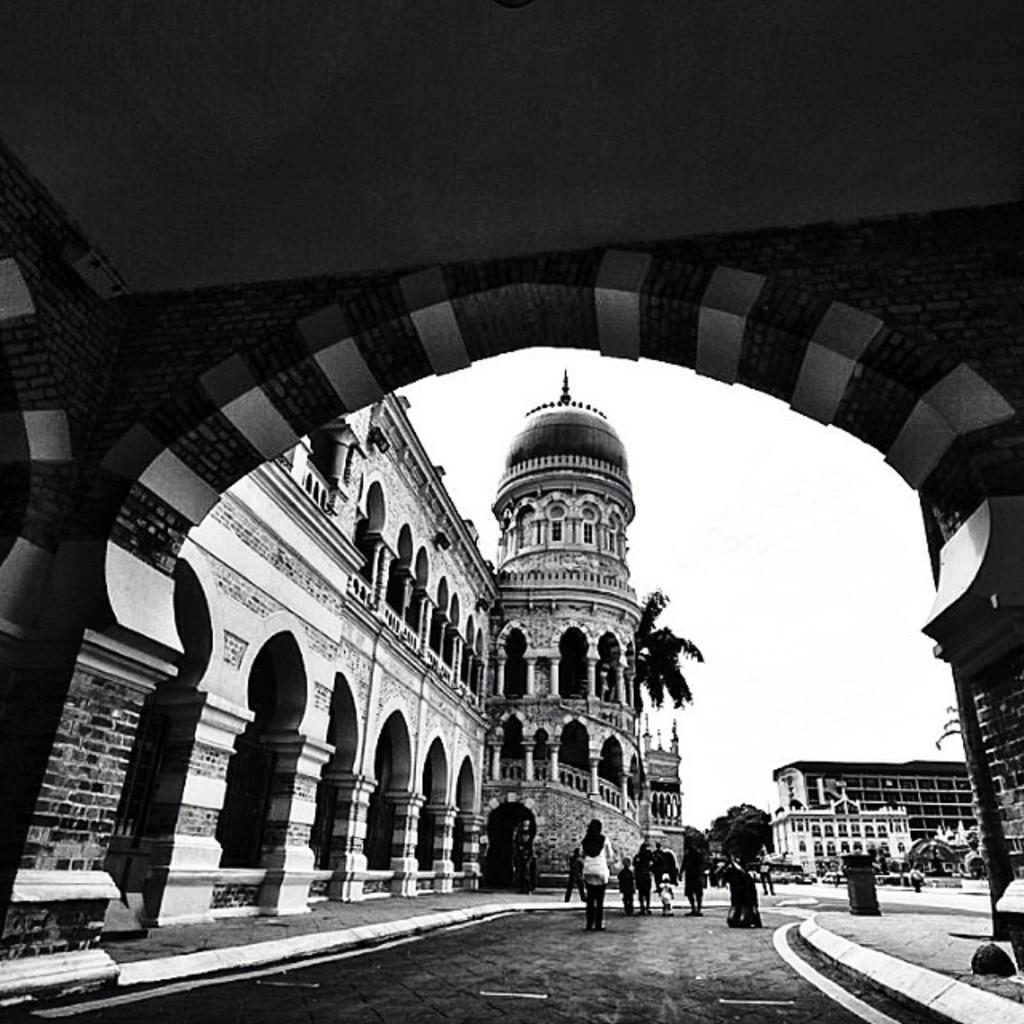What is the color scheme of the image? The image is black and white. What architectural feature can be seen in the image? There is an arch in the image. What type of structures are present in the image? There are buildings in the image. What natural elements are visible in the image? There are trees in the image. What object is used for waste disposal in the image? There is a bin in the image. Are there any people in the image? Yes, there are persons in the image. What is visible in the background of the image? The sky is visible in the background of the image. What type of cork can be seen in the image? There is no cork present in the image. How many noses can be seen on the persons in the image? It is not appropriate to count noses on the persons in the image, and the number of noses is not relevant to the content of the image. 